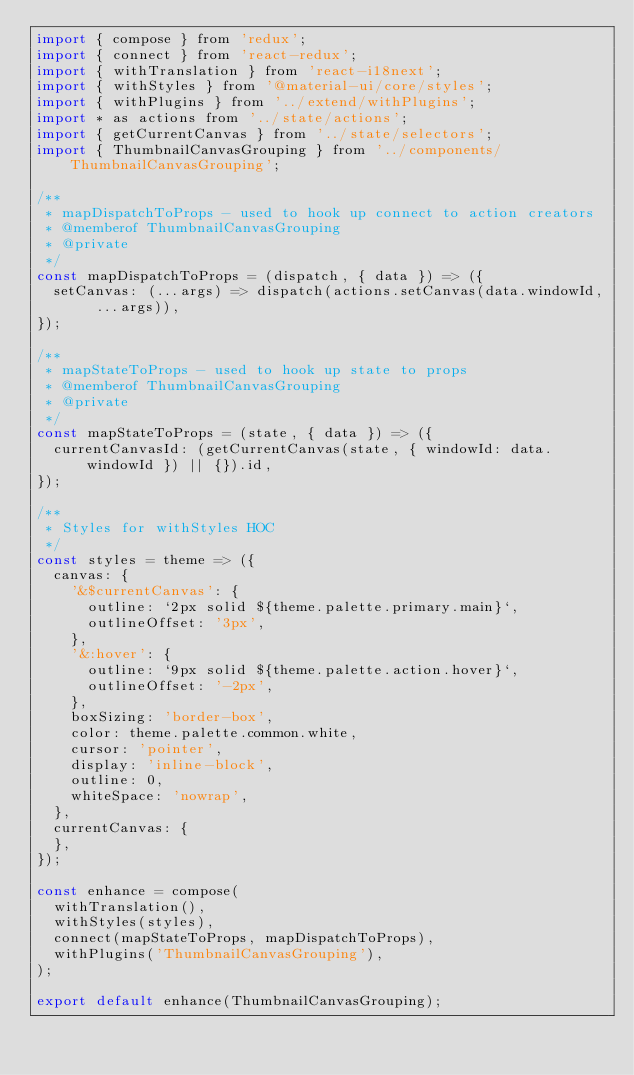Convert code to text. <code><loc_0><loc_0><loc_500><loc_500><_JavaScript_>import { compose } from 'redux';
import { connect } from 'react-redux';
import { withTranslation } from 'react-i18next';
import { withStyles } from '@material-ui/core/styles';
import { withPlugins } from '../extend/withPlugins';
import * as actions from '../state/actions';
import { getCurrentCanvas } from '../state/selectors';
import { ThumbnailCanvasGrouping } from '../components/ThumbnailCanvasGrouping';

/**
 * mapDispatchToProps - used to hook up connect to action creators
 * @memberof ThumbnailCanvasGrouping
 * @private
 */
const mapDispatchToProps = (dispatch, { data }) => ({
  setCanvas: (...args) => dispatch(actions.setCanvas(data.windowId, ...args)),
});

/**
 * mapStateToProps - used to hook up state to props
 * @memberof ThumbnailCanvasGrouping
 * @private
 */
const mapStateToProps = (state, { data }) => ({
  currentCanvasId: (getCurrentCanvas(state, { windowId: data.windowId }) || {}).id,
});

/**
 * Styles for withStyles HOC
 */
const styles = theme => ({
  canvas: {
    '&$currentCanvas': {
      outline: `2px solid ${theme.palette.primary.main}`,
      outlineOffset: '3px',
    },
    '&:hover': {
      outline: `9px solid ${theme.palette.action.hover}`,
      outlineOffset: '-2px',
    },
    boxSizing: 'border-box',
    color: theme.palette.common.white,
    cursor: 'pointer',
    display: 'inline-block',
    outline: 0,
    whiteSpace: 'nowrap',
  },
  currentCanvas: {
  },
});

const enhance = compose(
  withTranslation(),
  withStyles(styles),
  connect(mapStateToProps, mapDispatchToProps),
  withPlugins('ThumbnailCanvasGrouping'),
);

export default enhance(ThumbnailCanvasGrouping);
</code> 